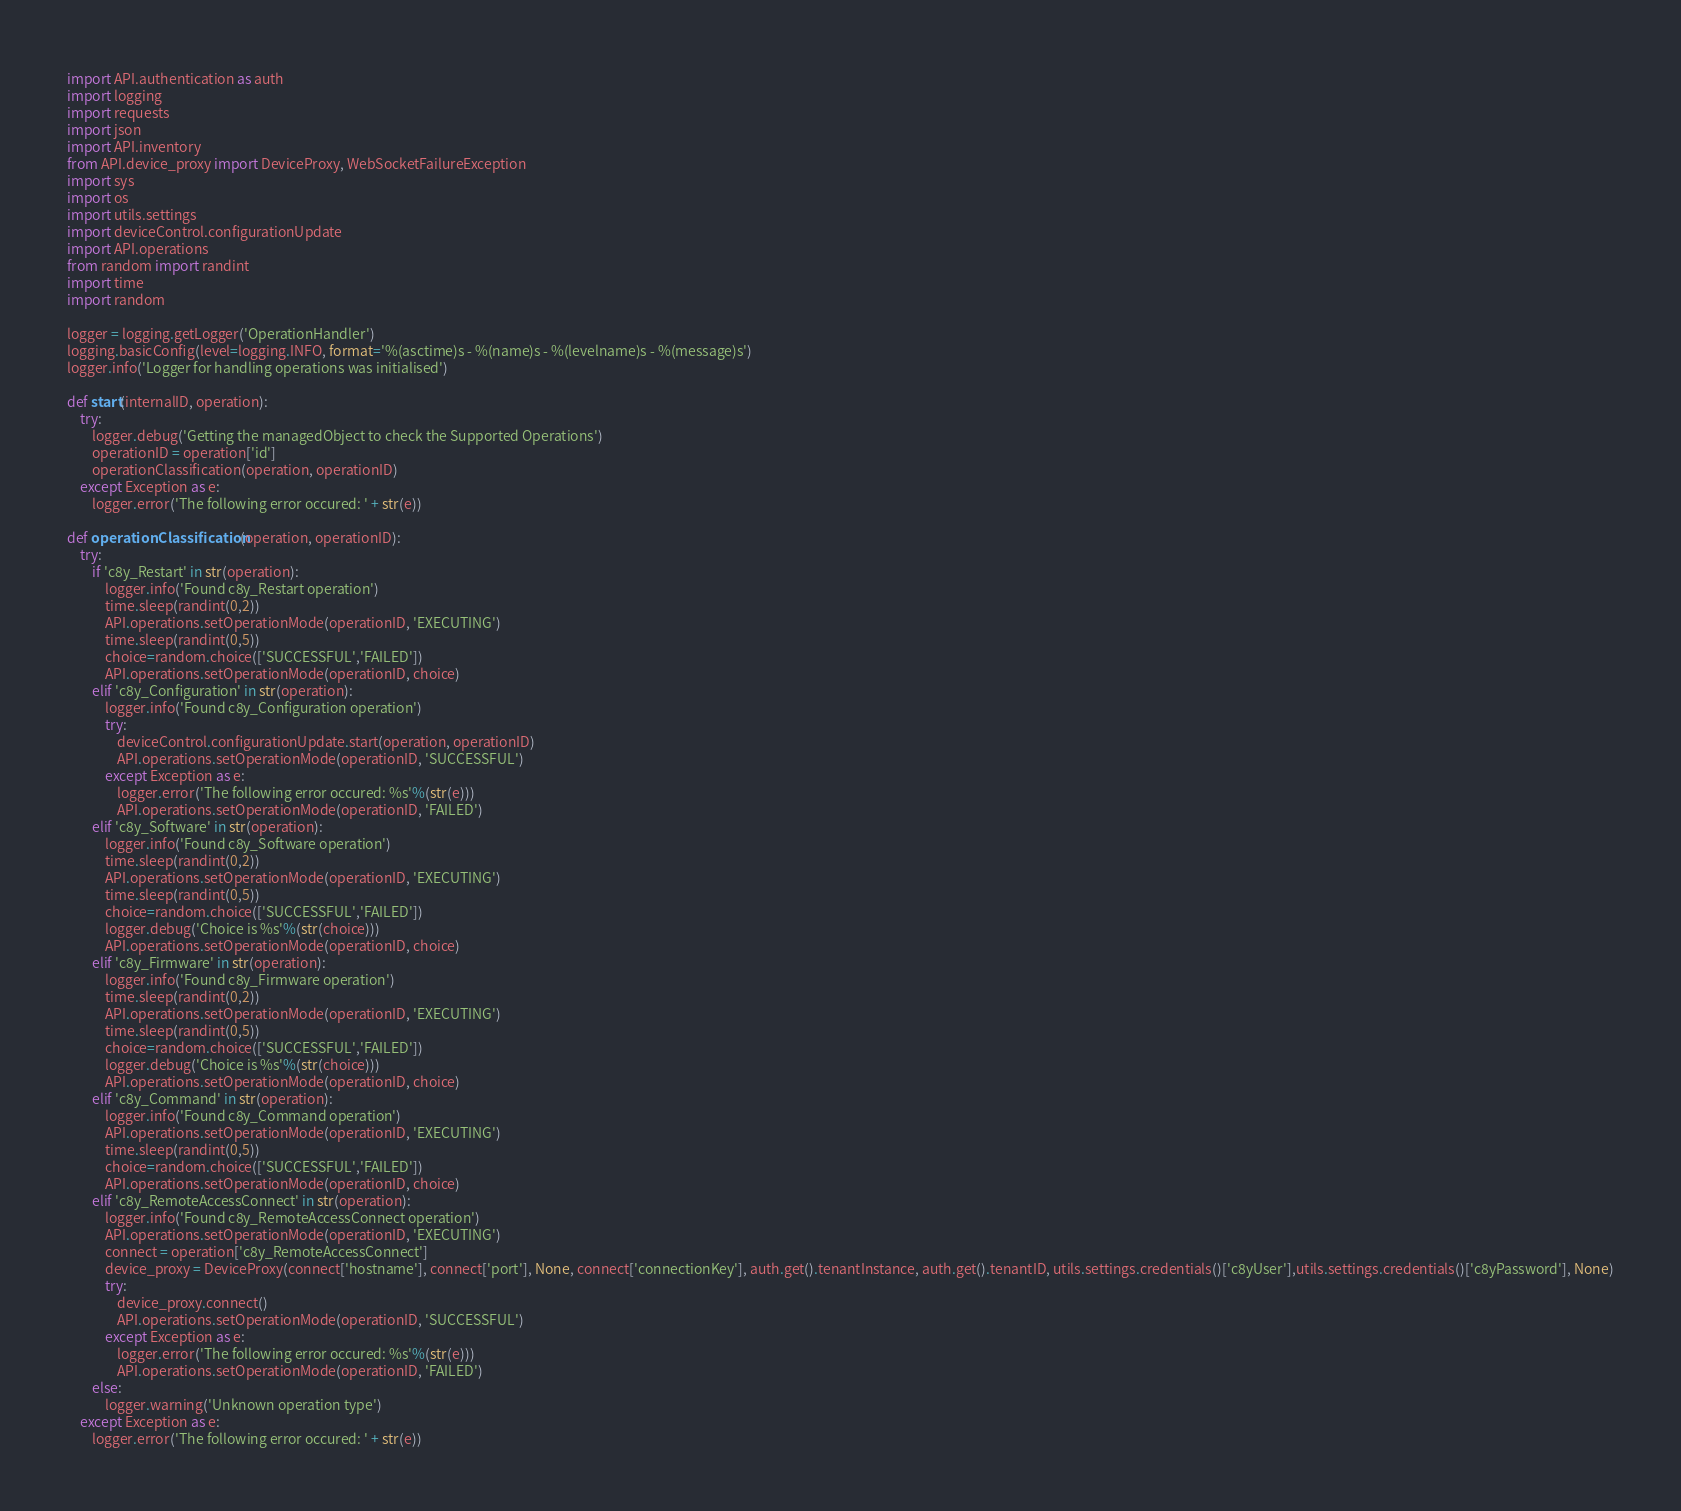Convert code to text. <code><loc_0><loc_0><loc_500><loc_500><_Python_>import API.authentication as auth
import logging
import requests
import json
import API.inventory
from API.device_proxy import DeviceProxy, WebSocketFailureException
import sys
import os
import utils.settings
import deviceControl.configurationUpdate
import API.operations
from random import randint
import time
import random

logger = logging.getLogger('OperationHandler')
logging.basicConfig(level=logging.INFO, format='%(asctime)s - %(name)s - %(levelname)s - %(message)s')
logger.info('Logger for handling operations was initialised')

def start(internalID, operation):
    try:
        logger.debug('Getting the managedObject to check the Supported Operations')
        operationID = operation['id']
        operationClassification(operation, operationID)
    except Exception as e:
        logger.error('The following error occured: ' + str(e))

def operationClassification(operation, operationID):
    try:
        if 'c8y_Restart' in str(operation):
            logger.info('Found c8y_Restart operation')
            time.sleep(randint(0,2))
            API.operations.setOperationMode(operationID, 'EXECUTING')
            time.sleep(randint(0,5))
            choice=random.choice(['SUCCESSFUL','FAILED'])
            API.operations.setOperationMode(operationID, choice)
        elif 'c8y_Configuration' in str(operation):
            logger.info('Found c8y_Configuration operation')
            try:
                deviceControl.configurationUpdate.start(operation, operationID)
                API.operations.setOperationMode(operationID, 'SUCCESSFUL')
            except Exception as e:
                logger.error('The following error occured: %s'%(str(e)))
                API.operations.setOperationMode(operationID, 'FAILED')
        elif 'c8y_Software' in str(operation):
            logger.info('Found c8y_Software operation')
            time.sleep(randint(0,2))
            API.operations.setOperationMode(operationID, 'EXECUTING')
            time.sleep(randint(0,5))
            choice=random.choice(['SUCCESSFUL','FAILED'])
            logger.debug('Choice is %s'%(str(choice)))
            API.operations.setOperationMode(operationID, choice)
        elif 'c8y_Firmware' in str(operation):
            logger.info('Found c8y_Firmware operation')
            time.sleep(randint(0,2))
            API.operations.setOperationMode(operationID, 'EXECUTING')
            time.sleep(randint(0,5))
            choice=random.choice(['SUCCESSFUL','FAILED'])
            logger.debug('Choice is %s'%(str(choice)))
            API.operations.setOperationMode(operationID, choice)
        elif 'c8y_Command' in str(operation):
            logger.info('Found c8y_Command operation')
            API.operations.setOperationMode(operationID, 'EXECUTING')
            time.sleep(randint(0,5))
            choice=random.choice(['SUCCESSFUL','FAILED'])
            API.operations.setOperationMode(operationID, choice)
        elif 'c8y_RemoteAccessConnect' in str(operation):
            logger.info('Found c8y_RemoteAccessConnect operation')
            API.operations.setOperationMode(operationID, 'EXECUTING')
            connect = operation['c8y_RemoteAccessConnect']
            device_proxy = DeviceProxy(connect['hostname'], connect['port'], None, connect['connectionKey'], auth.get().tenantInstance, auth.get().tenantID, utils.settings.credentials()['c8yUser'],utils.settings.credentials()['c8yPassword'], None)
            try:
                device_proxy.connect()
                API.operations.setOperationMode(operationID, 'SUCCESSFUL')
            except Exception as e:
                logger.error('The following error occured: %s'%(str(e)))
                API.operations.setOperationMode(operationID, 'FAILED')
        else:
            logger.warning('Unknown operation type')
    except Exception as e:
        logger.error('The following error occured: ' + str(e))
</code> 